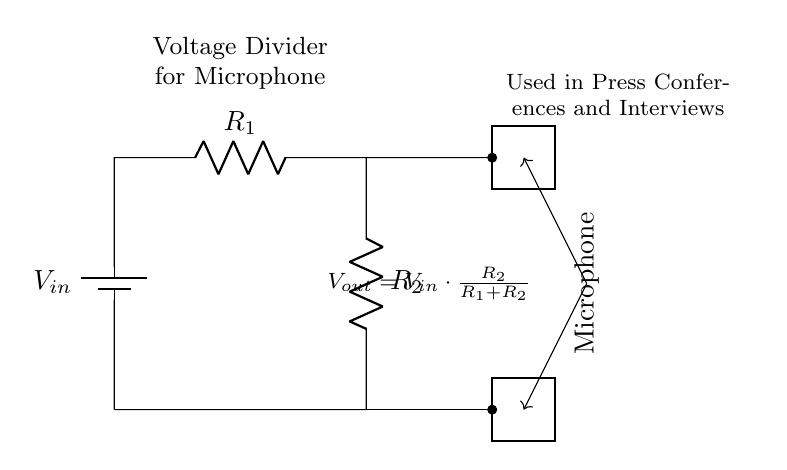What is the input voltage? The input voltage is represented by the label "V_in" connected to the top of the circuit. Since no specific value is provided in the diagram, we denote it as "V_in".
Answer: V_in What are the resistances in the circuit? The circuit includes two resistors labeled as "R_1" and "R_2". These resistances are part of the voltage divider configuration.
Answer: R_1, R_2 What is the output voltage formula? The diagram indicates the output voltage as "V_out = V_in * (R_2 / (R_1 + R_2))", which describes how the output voltage is determined based on the input voltage and resistance values.
Answer: V_out = V_in * (R_2 / (R_1 + R_2)) Which component acts as the load in this circuit? The microphone, represented by a thick rectangle labeled "Microphone", is the load connected to the output of the voltage divider. The microphone converts the electrical signal into sound.
Answer: Microphone How does changing R_1 affect V_out? Increasing R_1 will increase the total resistance in the denominator of the output voltage equation, thus decreasing V_out. Consequently, this alters the voltage supplied to the microphone.
Answer: Decreases V_out What purpose does a voltage divider serve in this circuit? A voltage divider is used to reduce the voltage to a desired level suitable for the microphone, ensuring it operates effectively without distortion or damage from excessive voltage.
Answer: Voltage reduction 